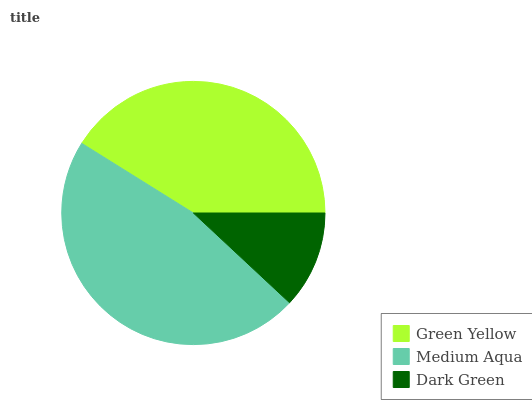Is Dark Green the minimum?
Answer yes or no. Yes. Is Medium Aqua the maximum?
Answer yes or no. Yes. Is Medium Aqua the minimum?
Answer yes or no. No. Is Dark Green the maximum?
Answer yes or no. No. Is Medium Aqua greater than Dark Green?
Answer yes or no. Yes. Is Dark Green less than Medium Aqua?
Answer yes or no. Yes. Is Dark Green greater than Medium Aqua?
Answer yes or no. No. Is Medium Aqua less than Dark Green?
Answer yes or no. No. Is Green Yellow the high median?
Answer yes or no. Yes. Is Green Yellow the low median?
Answer yes or no. Yes. Is Medium Aqua the high median?
Answer yes or no. No. Is Dark Green the low median?
Answer yes or no. No. 